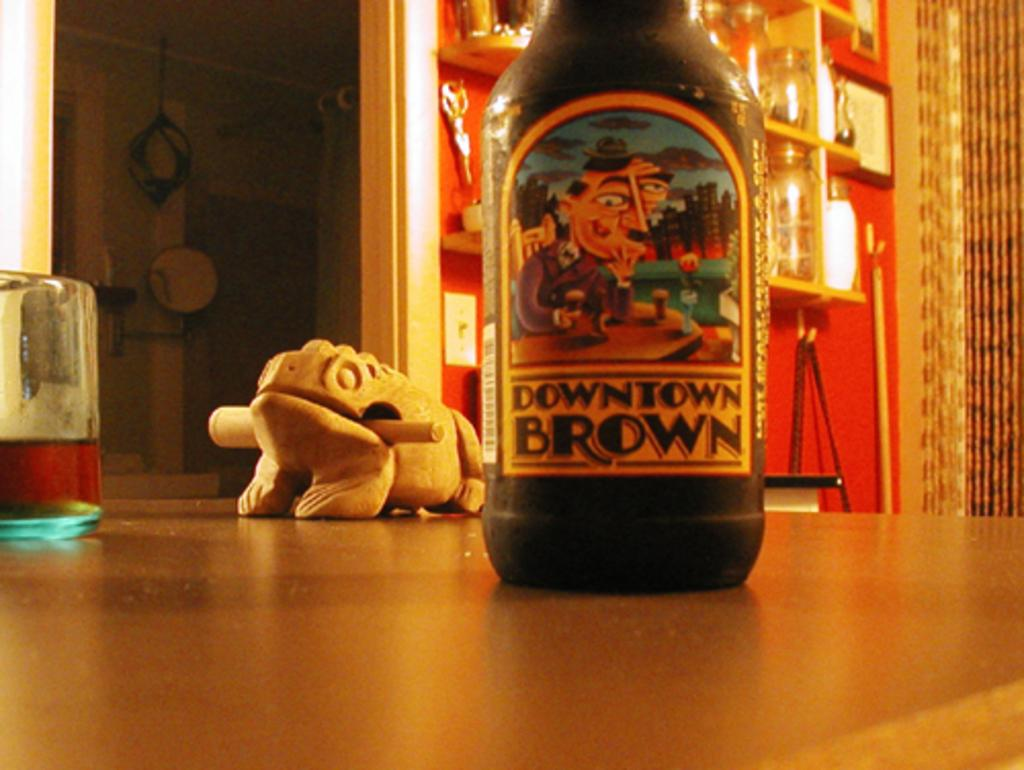<image>
Create a compact narrative representing the image presented. A bottle with the brand Downtown Brown on the logo is on a table. 